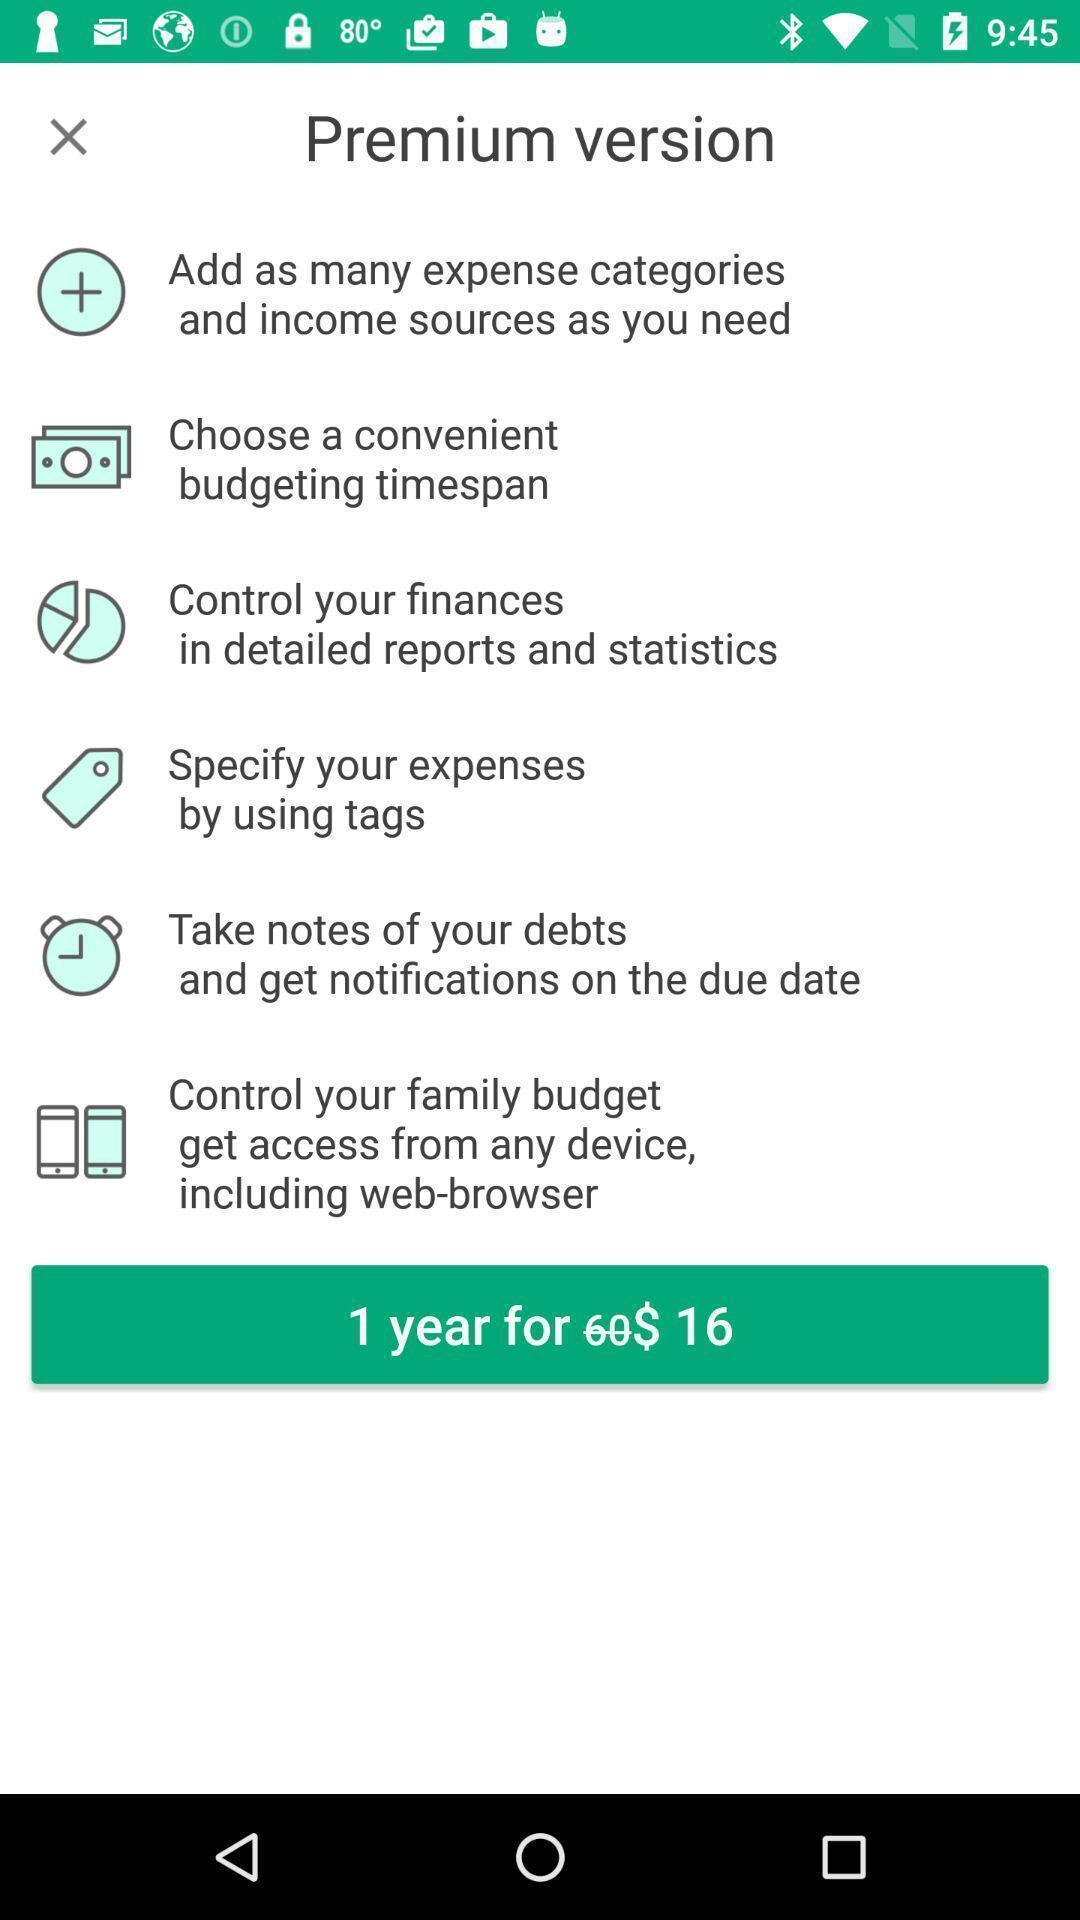Provide a textual representation of this image. Screen displays about premium version. 